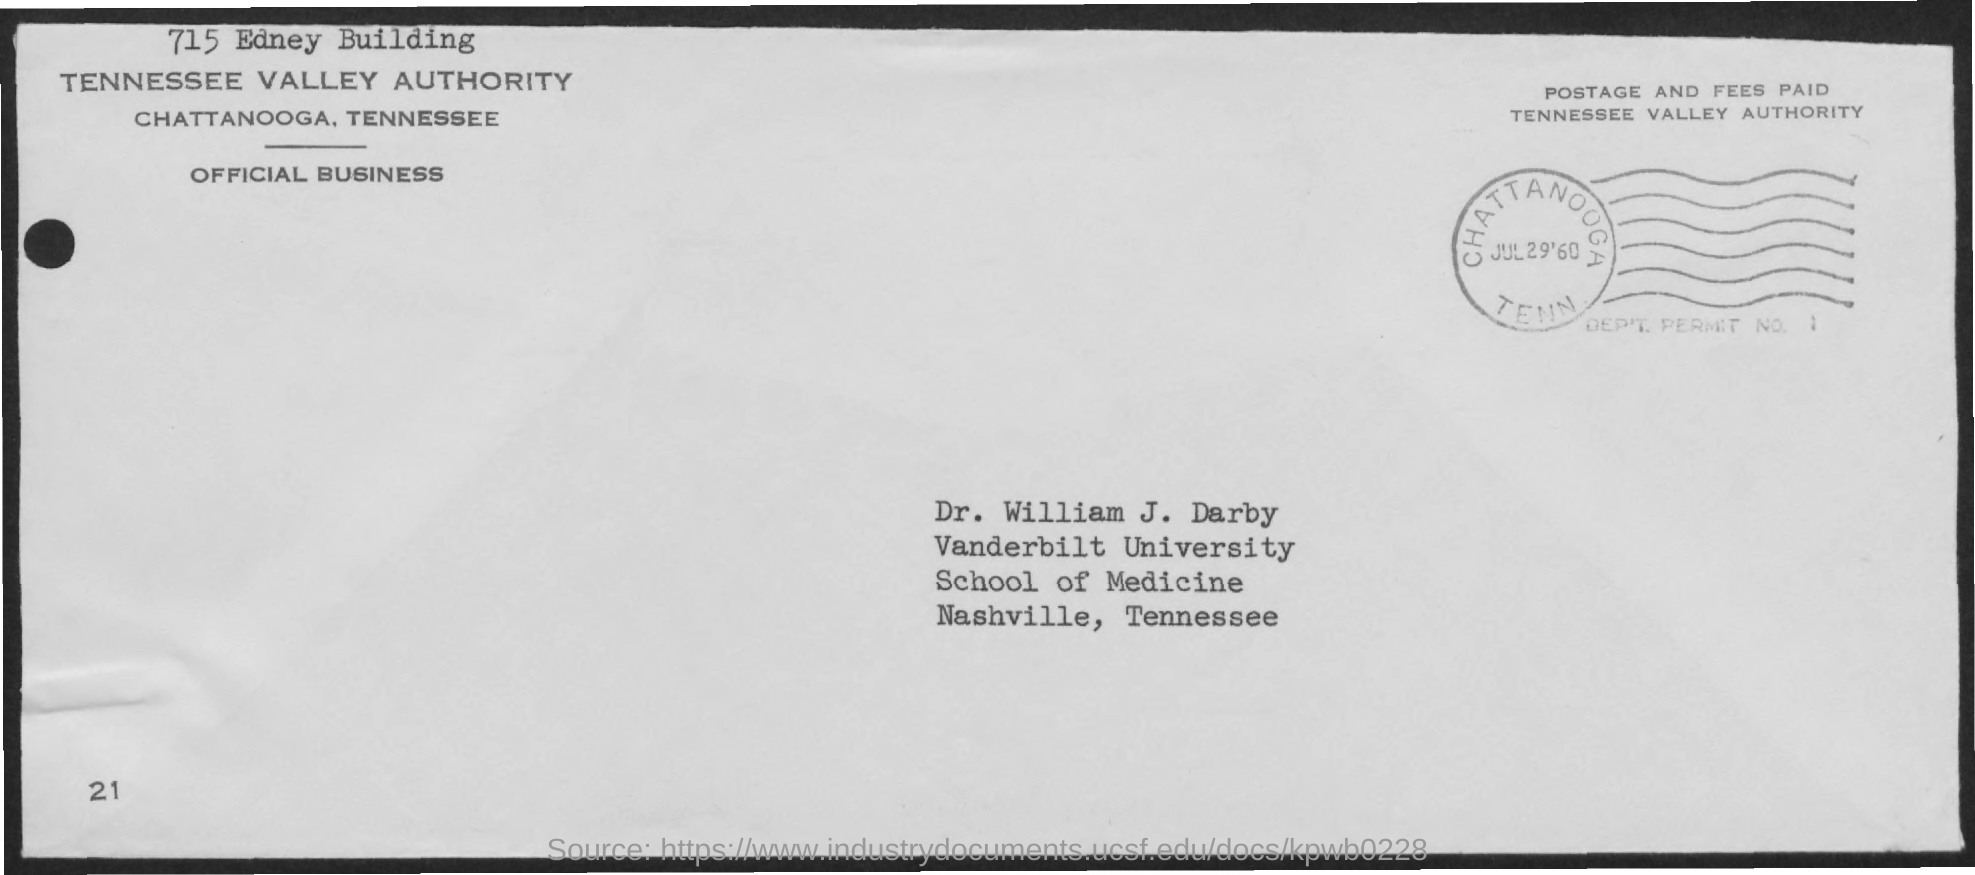What is the name of the person given in the address?
Offer a terse response. Dr. William J. Darby. In which University Dr. William J. Darby works?
Your answer should be very brief. Vanderbilt University. 